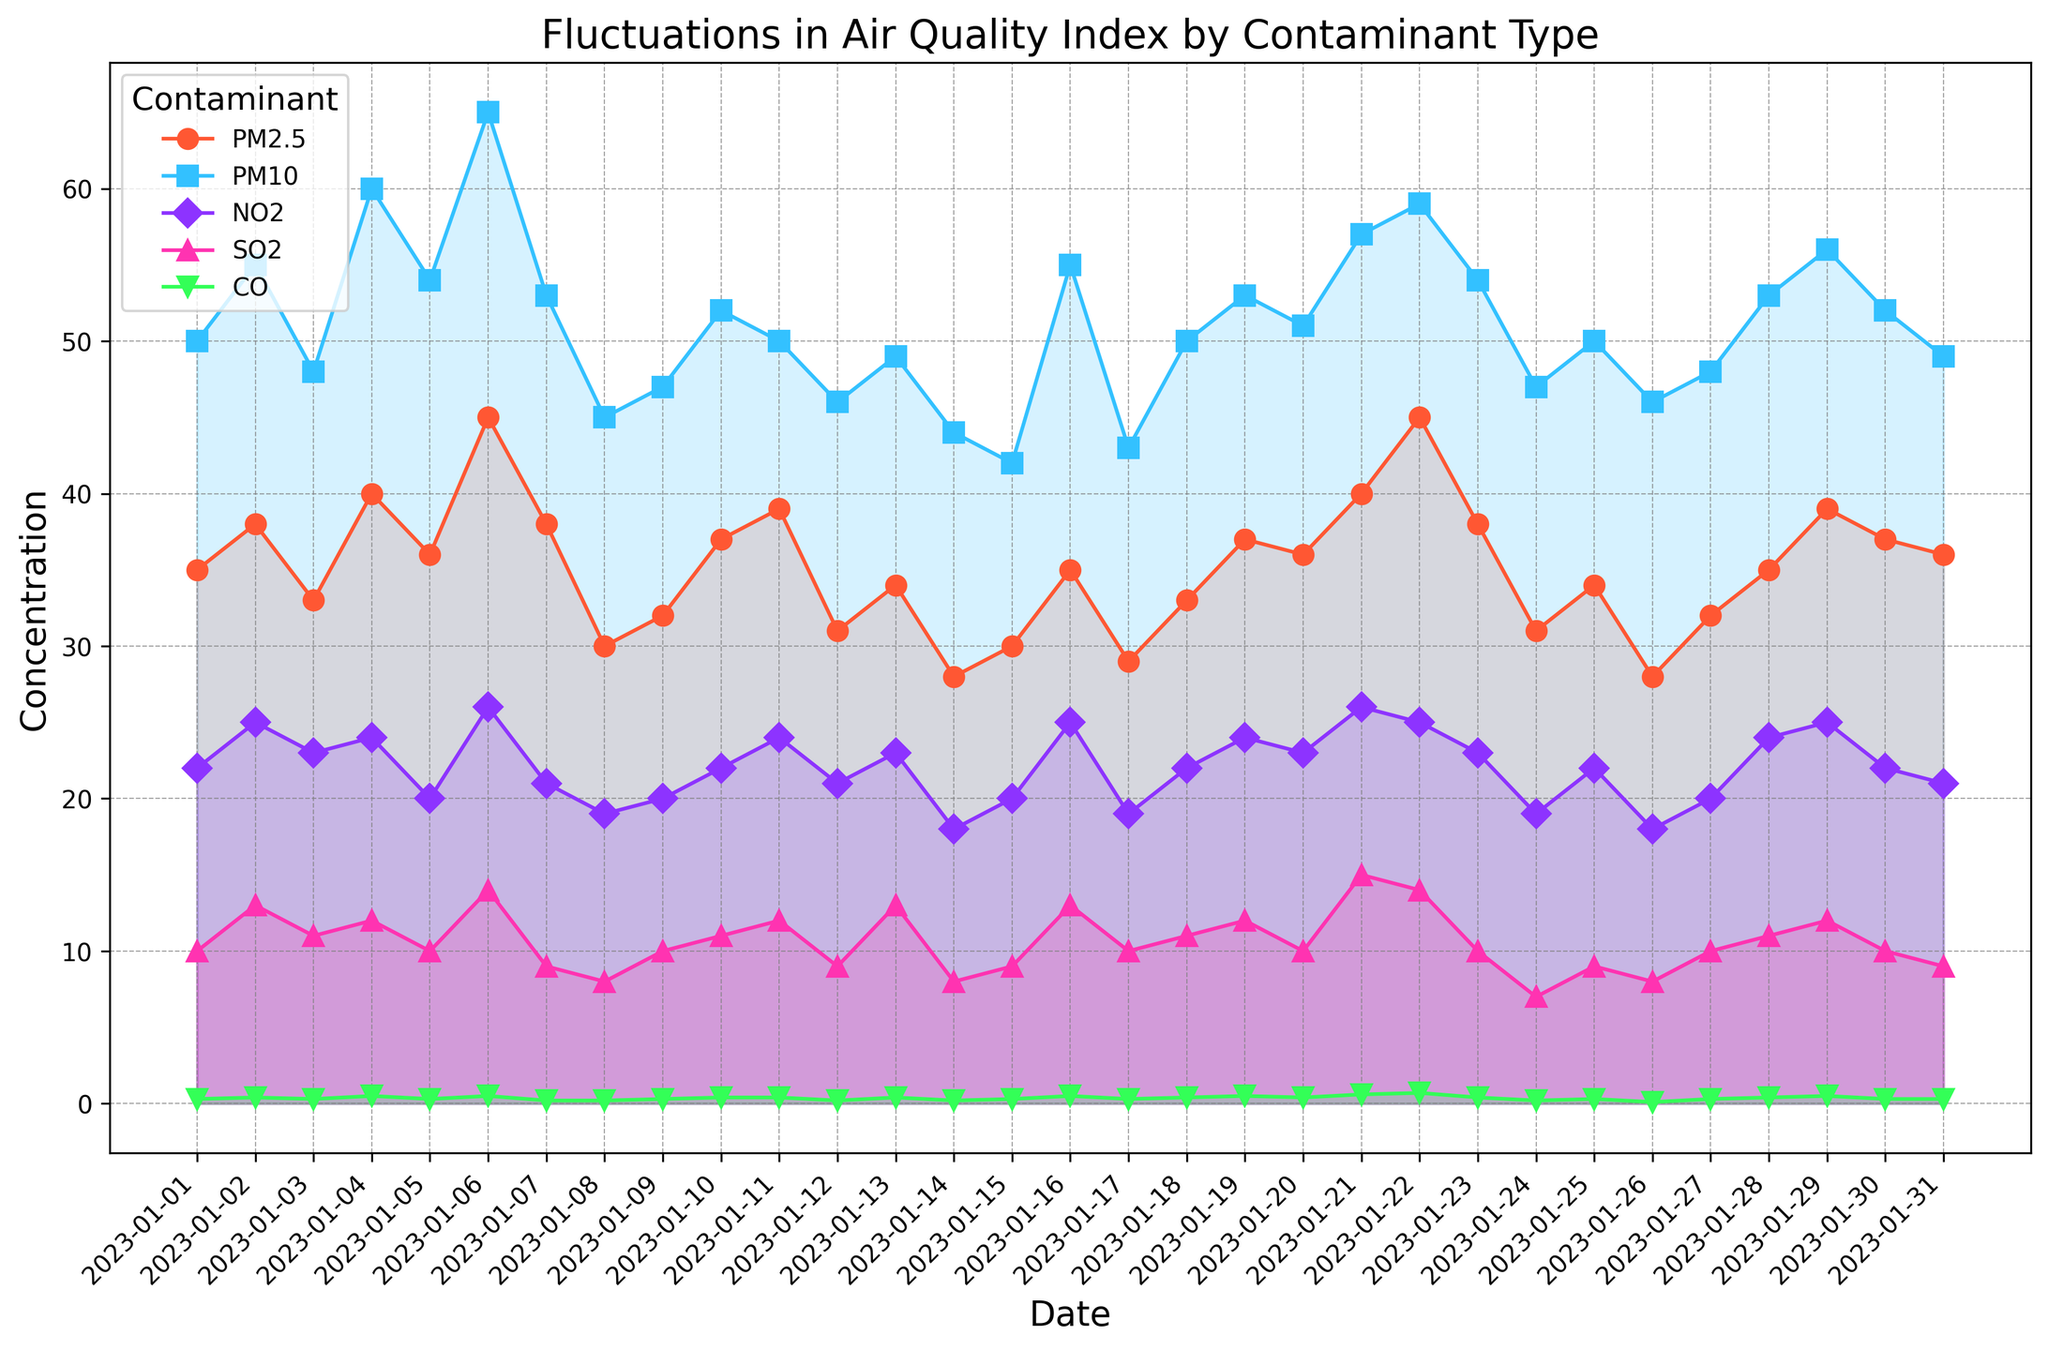What contaminant shows the highest concentration on January 21? The figure shows multiple lines with different markers and filled areas representing different contaminants. By examining the data points on January 21st, the line associated with PM10 appears the highest.
Answer: PM10 On which date did CO reach its peak concentration? Check for the highest point among the green lines representing CO across all dates. The peak concentration of CO is observed on January 22nd.
Answer: January 22 Which two days have the largest difference in PM2.5 concentrations? Look at the PM2.5 line and identify the days with the biggest difference between consecutive points. The steepest change happens between January 6th and January 7th.
Answer: January 6 and January 7 Which contaminant exhibits the most fluctuation over the period? Examine the lines representing each contaminant and observe their up-and-down variations. The PM2.5 line shows more frequent and noticeable fluctuations compared to other contaminants.
Answer: PM2.5 What's the sum of SO2 levels on January 10 and January 11? Refer to the points for SO2 on the mentioned dates. SO2 on January 10 is 11 and on January 11 is 12. Summing them up gives 11 + 12 = 23.
Answer: 23 Between PM2.5 and NO2, which contaminant has a higher average concentration over the period? Calculate the average PM2.5 concentration by summing all values and dividing by the number of days, then do the same for NO2. Average PM2.5 ≈ 35, NO2 ≈ 22, so PM2.5 is higher.
Answer: PM2.5 Which contaminant has the smallest concentration on January 28th? Identify the lowest value among the contaminants for January 28. CO has the smallest concentration, appearing as the green line.
Answer: CO Which color represents the highest concentration of PM10 on January 4th? Locate the PM10 data point on January 4 and identify the associated color in the filled area between lines. The color representing PM10 is blue.
Answer: Blue What is the difference in PM10 levels between January 1 and January 13? Check the PM10 values for January 1 and January 13. January 1 has 50, and January 13 has 49. The difference is 50 - 49 = 1.
Answer: 1 Over the entire period, which contaminant tends to have the most stable concentration? Evaluate the various graphs and notice that the SO2 line (pink) varies the least.
Answer: SO2 